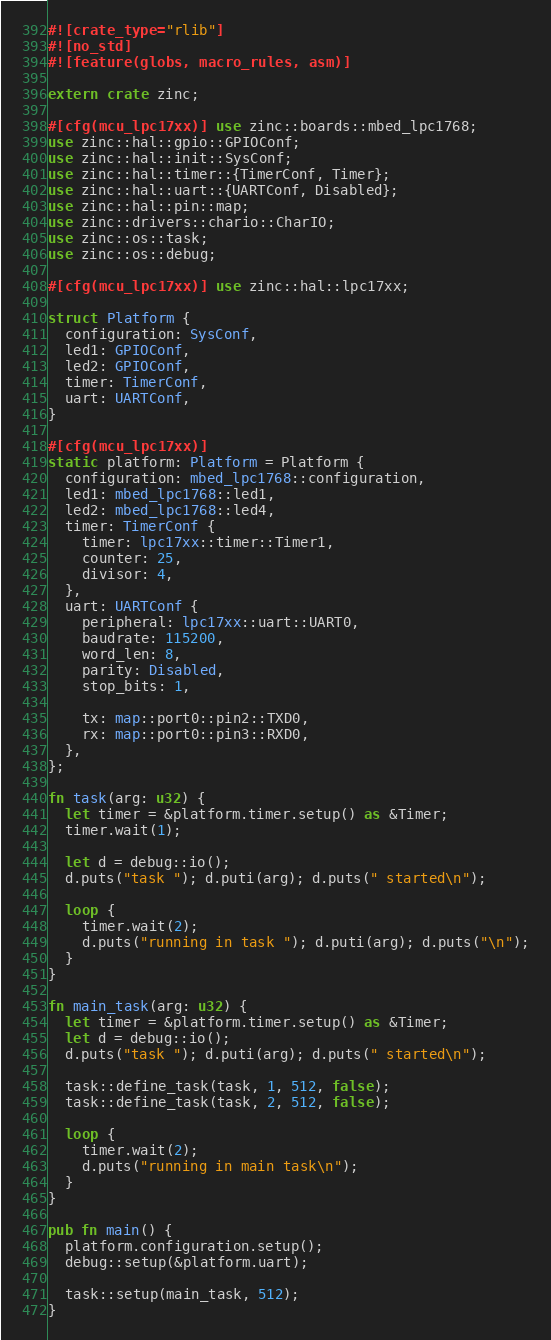Convert code to text. <code><loc_0><loc_0><loc_500><loc_500><_Rust_>#![crate_type="rlib"]
#![no_std]
#![feature(globs, macro_rules, asm)]

extern crate zinc;

#[cfg(mcu_lpc17xx)] use zinc::boards::mbed_lpc1768;
use zinc::hal::gpio::GPIOConf;
use zinc::hal::init::SysConf;
use zinc::hal::timer::{TimerConf, Timer};
use zinc::hal::uart::{UARTConf, Disabled};
use zinc::hal::pin::map;
use zinc::drivers::chario::CharIO;
use zinc::os::task;
use zinc::os::debug;

#[cfg(mcu_lpc17xx)] use zinc::hal::lpc17xx;

struct Platform {
  configuration: SysConf,
  led1: GPIOConf,
  led2: GPIOConf,
  timer: TimerConf,
  uart: UARTConf,
}

#[cfg(mcu_lpc17xx)]
static platform: Platform = Platform {
  configuration: mbed_lpc1768::configuration,
  led1: mbed_lpc1768::led1,
  led2: mbed_lpc1768::led4,
  timer: TimerConf {
    timer: lpc17xx::timer::Timer1,
    counter: 25,
    divisor: 4,
  },
  uart: UARTConf {
    peripheral: lpc17xx::uart::UART0,
    baudrate: 115200,
    word_len: 8,
    parity: Disabled,
    stop_bits: 1,

    tx: map::port0::pin2::TXD0,
    rx: map::port0::pin3::RXD0,
  },
};

fn task(arg: u32) {
  let timer = &platform.timer.setup() as &Timer;
  timer.wait(1);

  let d = debug::io();
  d.puts("task "); d.puti(arg); d.puts(" started\n");

  loop {
    timer.wait(2);
    d.puts("running in task "); d.puti(arg); d.puts("\n");
  }
}

fn main_task(arg: u32) {
  let timer = &platform.timer.setup() as &Timer;
  let d = debug::io();
  d.puts("task "); d.puti(arg); d.puts(" started\n");

  task::define_task(task, 1, 512, false);
  task::define_task(task, 2, 512, false);

  loop {
    timer.wait(2);
    d.puts("running in main task\n");
  }
}

pub fn main() {
  platform.configuration.setup();
  debug::setup(&platform.uart);

  task::setup(main_task, 512);
}
</code> 